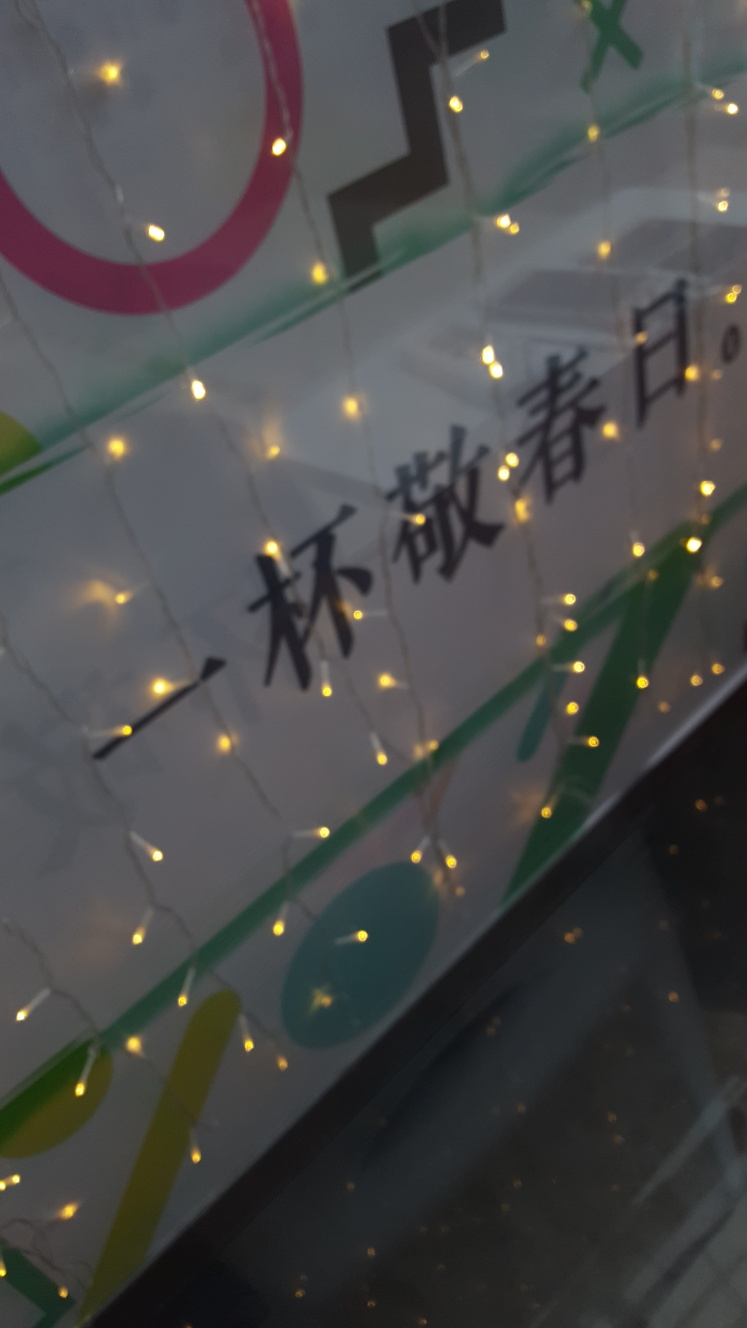Are these lights being used for a special occasion? Without additional context, it's difficult to determine the specific occasion, but such lights are commonly used to add a decorative touch during holidays, parties, or other special events. The pattern and placement of the lights here suggest they are intended to create a festive or decorative ambience, potentially for an event or simply for ambiance. 